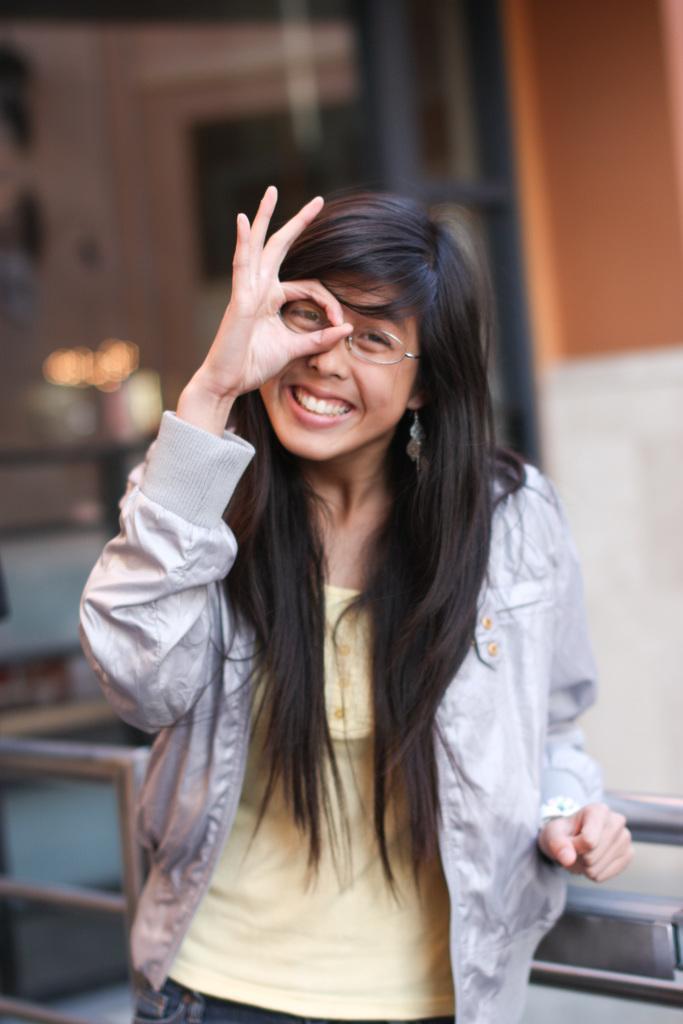Can you describe this image briefly? In the center of the image we can see a person is standing and she is smiling. And we can see she is in a different costume and she is wearing glasses. Behind her, there is a fence. In the background, we can see it is blurred. 